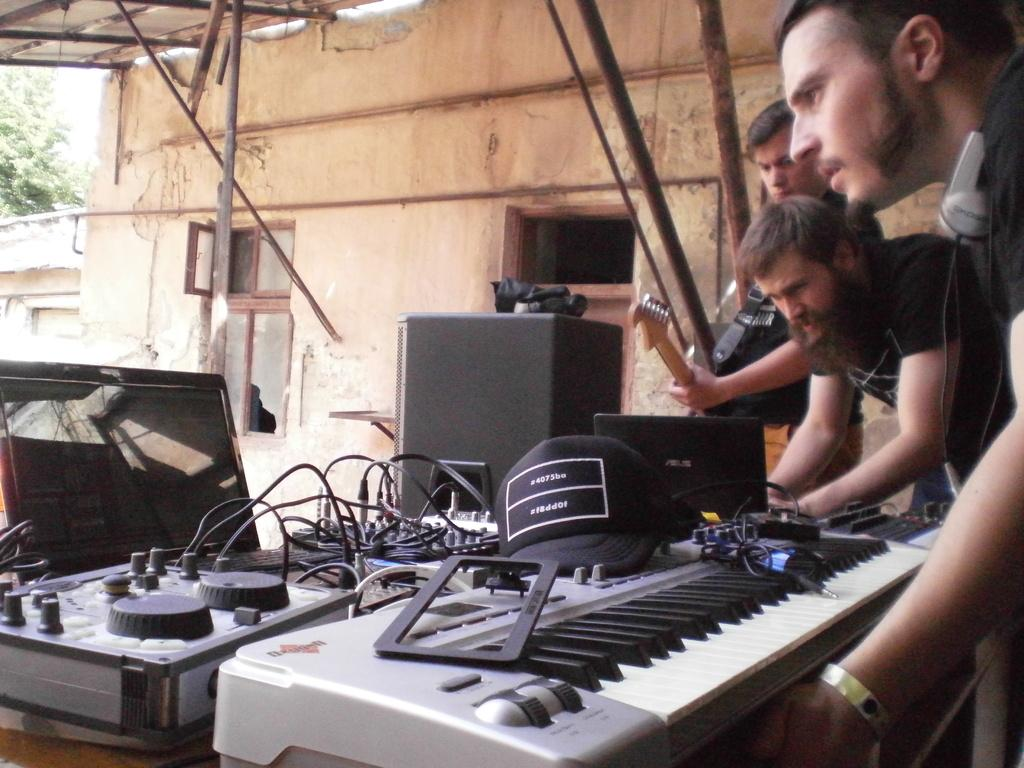What is the color of the wall in the image? The wall in the image is white. How many people are present in the image? There are three people in the image. What is one of the people holding? One of the people is holding a guitar. What musical instrument can also be seen in the image? There is a musical keyboard in the image. What is the value of the army in the image? There is no army present in the image, so it is not possible to determine its value. 